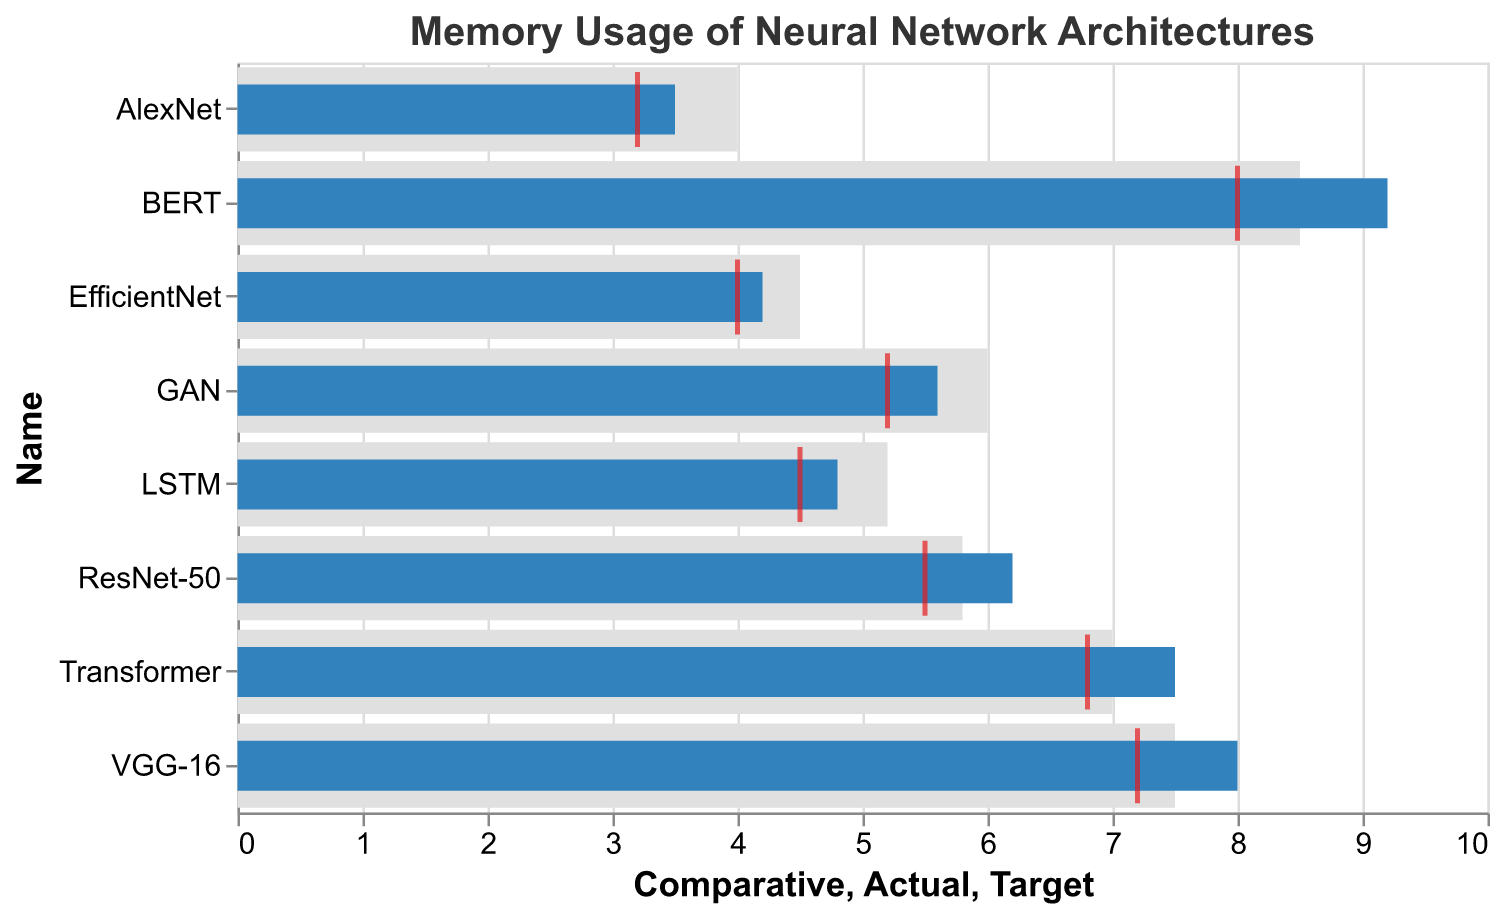What is the title of the chart? The title of the chart is displayed at the top and typically summarizes the content of the chart. Here, it is written as "Memory Usage of Neural Network Architectures".
Answer: Memory Usage of Neural Network Architectures What does the red tick mark represent in the chart? In a bullet chart, the red tick mark usually represents the target value. Upon observing the chart, the red ticks correspond to the 'Target' column values for each neural network architecture.
Answer: Target Value Which neural network architecture uses the highest amount of memory? By examining the lengths of the blue bars representing the 'Actual' memory usage, BERT has the longest bar, indicating the highest memory usage.
Answer: BERT How does EfficientNet's actual memory usage compare to its target memory usage? EfficientNet's actual memory usage (4.2) can be compared to its target memory usage (4.0) by noting the blue bar's position relative to the red tick. The blue bar extends slightly past the red tick mark.
Answer: 0.2 units more Which architectures exceed their target memory usage the most? The gap between the blue bars (Actual) and red ticks (Target) can be noted. BERT has the largest gap between these values.
Answer: BERT Is there any architecture that uses less memory than its comparative benchmark? By comparing the blue bars (Actual) to the gray bars (Comparative), we can see that only the LSTM architecture's actual memory usage (4.8) is less than its comparative benchmark (5.2).
Answer: LSTM Among ResNet-50 and Transformer, which one is closer to meeting its target memory usage? ResNet-50's actual usage (6.2) is compared to its target (5.5), and similarly for Transformer (7.5 actual vs. 6.8 target). The smaller difference for ResNet-50 (0.7) vs. Transformer (0.7) indicates ResNet-50 is relatively closer.
Answer: ResNet-50 What is the range of comparative memory usages across all architectures? Examine the comparative benchmarks (gray bars) to find the minimum and maximum values. The lowest comparative value is for AlexNet (4.0) and the highest is for BERT (8.5). The range is 8.5 - 4.0.
Answer: 4.5 Which architectures have a comparative value greater than their actual memory usage? Compare the comparative values to the actual values. Those where the grey bar is longer than the blue bar include AlexNet (comparative 4.0, actual 3.5) and GAN (comparative 6.0, actual 5.6).
Answer: AlexNet and GAN How does the actual memory usage of VGG-16 compare to Transformer in relation to their targets? Compute the difference between the actual and target values for both architectures. VGG-16's difference is 8.0 - 7.2 = 0.8. Transformer's is 7.5 - 6.8 = 0.7. VGG-16 exceeds its target by a larger margin.
Answer: VGG-16 exceeds more What is the median actual memory usage among all the architectures? First, list the actual usage values: 3.5, 4.2, 4.8, 5.6, 6.2, 7.5, 8.0, 9.2. As there are eight values, the median is the average of the 4th and 5th values in sorted order: (5.6 + 6.2)/2.
Answer: 5.9 